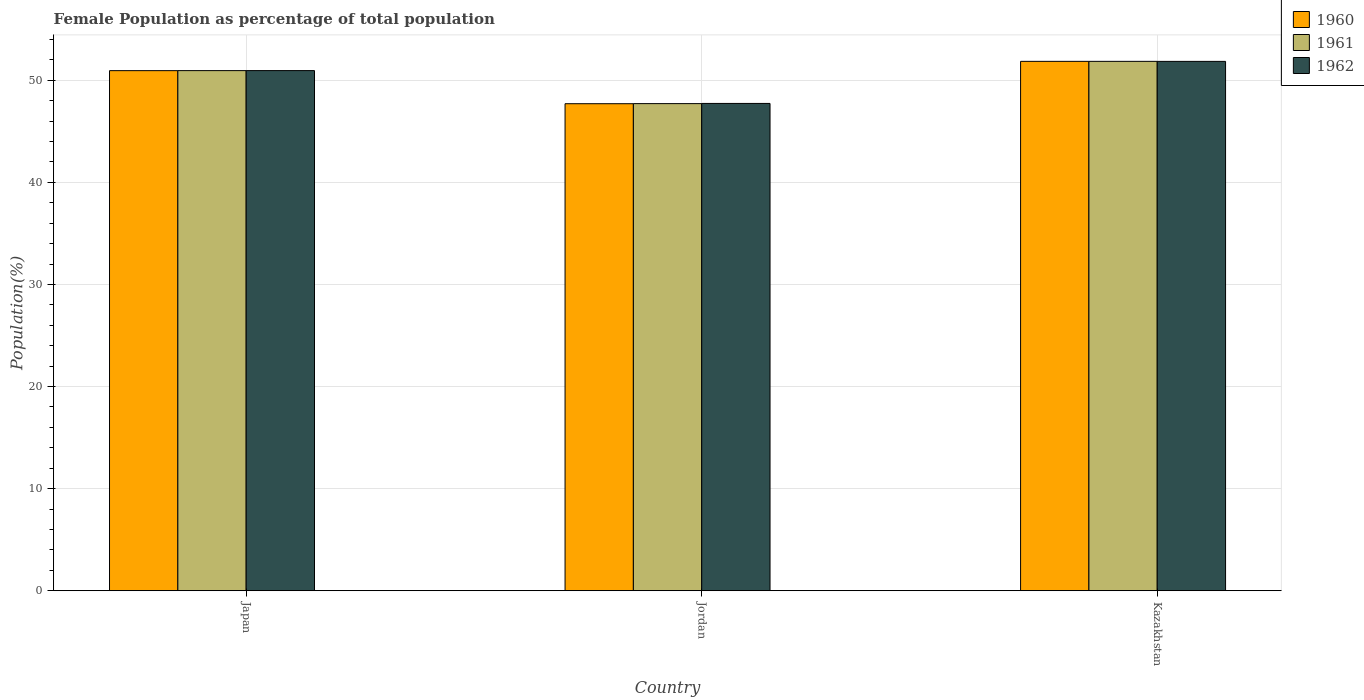How many bars are there on the 2nd tick from the left?
Your response must be concise. 3. How many bars are there on the 3rd tick from the right?
Your answer should be compact. 3. What is the label of the 3rd group of bars from the left?
Offer a very short reply. Kazakhstan. What is the female population in in 1960 in Kazakhstan?
Give a very brief answer. 51.85. Across all countries, what is the maximum female population in in 1962?
Offer a terse response. 51.85. Across all countries, what is the minimum female population in in 1961?
Give a very brief answer. 47.71. In which country was the female population in in 1961 maximum?
Ensure brevity in your answer.  Kazakhstan. In which country was the female population in in 1960 minimum?
Keep it short and to the point. Jordan. What is the total female population in in 1961 in the graph?
Make the answer very short. 150.51. What is the difference between the female population in in 1960 in Jordan and that in Kazakhstan?
Provide a short and direct response. -4.15. What is the difference between the female population in in 1962 in Kazakhstan and the female population in in 1961 in Japan?
Provide a short and direct response. 0.9. What is the average female population in in 1961 per country?
Your response must be concise. 50.17. What is the difference between the female population in of/in 1962 and female population in of/in 1961 in Kazakhstan?
Provide a short and direct response. -0. In how many countries, is the female population in in 1962 greater than 8 %?
Offer a very short reply. 3. What is the ratio of the female population in in 1962 in Japan to that in Kazakhstan?
Your response must be concise. 0.98. Is the difference between the female population in in 1962 in Japan and Jordan greater than the difference between the female population in in 1961 in Japan and Jordan?
Offer a terse response. No. What is the difference between the highest and the second highest female population in in 1961?
Offer a terse response. -0.91. What is the difference between the highest and the lowest female population in in 1962?
Your answer should be compact. 4.12. Is the sum of the female population in in 1960 in Japan and Jordan greater than the maximum female population in in 1961 across all countries?
Your response must be concise. Yes. What does the 1st bar from the right in Kazakhstan represents?
Keep it short and to the point. 1962. Is it the case that in every country, the sum of the female population in in 1960 and female population in in 1962 is greater than the female population in in 1961?
Offer a very short reply. Yes. How many bars are there?
Give a very brief answer. 9. What is the difference between two consecutive major ticks on the Y-axis?
Provide a short and direct response. 10. How are the legend labels stacked?
Your response must be concise. Vertical. What is the title of the graph?
Your answer should be very brief. Female Population as percentage of total population. What is the label or title of the X-axis?
Ensure brevity in your answer.  Country. What is the label or title of the Y-axis?
Ensure brevity in your answer.  Population(%). What is the Population(%) in 1960 in Japan?
Make the answer very short. 50.94. What is the Population(%) in 1961 in Japan?
Ensure brevity in your answer.  50.94. What is the Population(%) in 1962 in Japan?
Your answer should be compact. 50.95. What is the Population(%) in 1960 in Jordan?
Keep it short and to the point. 47.7. What is the Population(%) in 1961 in Jordan?
Your response must be concise. 47.71. What is the Population(%) of 1962 in Jordan?
Offer a terse response. 47.73. What is the Population(%) of 1960 in Kazakhstan?
Offer a terse response. 51.85. What is the Population(%) in 1961 in Kazakhstan?
Provide a succinct answer. 51.85. What is the Population(%) of 1962 in Kazakhstan?
Make the answer very short. 51.85. Across all countries, what is the maximum Population(%) of 1960?
Provide a short and direct response. 51.85. Across all countries, what is the maximum Population(%) of 1961?
Ensure brevity in your answer.  51.85. Across all countries, what is the maximum Population(%) in 1962?
Your answer should be very brief. 51.85. Across all countries, what is the minimum Population(%) of 1960?
Your answer should be very brief. 47.7. Across all countries, what is the minimum Population(%) of 1961?
Your answer should be compact. 47.71. Across all countries, what is the minimum Population(%) in 1962?
Provide a short and direct response. 47.73. What is the total Population(%) of 1960 in the graph?
Offer a very short reply. 150.5. What is the total Population(%) in 1961 in the graph?
Ensure brevity in your answer.  150.51. What is the total Population(%) of 1962 in the graph?
Keep it short and to the point. 150.52. What is the difference between the Population(%) in 1960 in Japan and that in Jordan?
Offer a very short reply. 3.24. What is the difference between the Population(%) in 1961 in Japan and that in Jordan?
Provide a short and direct response. 3.23. What is the difference between the Population(%) in 1962 in Japan and that in Jordan?
Make the answer very short. 3.21. What is the difference between the Population(%) of 1960 in Japan and that in Kazakhstan?
Give a very brief answer. -0.91. What is the difference between the Population(%) of 1961 in Japan and that in Kazakhstan?
Your answer should be very brief. -0.91. What is the difference between the Population(%) of 1962 in Japan and that in Kazakhstan?
Keep it short and to the point. -0.9. What is the difference between the Population(%) of 1960 in Jordan and that in Kazakhstan?
Your response must be concise. -4.15. What is the difference between the Population(%) of 1961 in Jordan and that in Kazakhstan?
Offer a terse response. -4.14. What is the difference between the Population(%) in 1962 in Jordan and that in Kazakhstan?
Offer a very short reply. -4.12. What is the difference between the Population(%) in 1960 in Japan and the Population(%) in 1961 in Jordan?
Ensure brevity in your answer.  3.23. What is the difference between the Population(%) in 1960 in Japan and the Population(%) in 1962 in Jordan?
Your answer should be compact. 3.21. What is the difference between the Population(%) of 1961 in Japan and the Population(%) of 1962 in Jordan?
Give a very brief answer. 3.21. What is the difference between the Population(%) in 1960 in Japan and the Population(%) in 1961 in Kazakhstan?
Offer a very short reply. -0.91. What is the difference between the Population(%) in 1960 in Japan and the Population(%) in 1962 in Kazakhstan?
Keep it short and to the point. -0.91. What is the difference between the Population(%) of 1961 in Japan and the Population(%) of 1962 in Kazakhstan?
Ensure brevity in your answer.  -0.9. What is the difference between the Population(%) of 1960 in Jordan and the Population(%) of 1961 in Kazakhstan?
Offer a terse response. -4.15. What is the difference between the Population(%) in 1960 in Jordan and the Population(%) in 1962 in Kazakhstan?
Ensure brevity in your answer.  -4.15. What is the difference between the Population(%) in 1961 in Jordan and the Population(%) in 1962 in Kazakhstan?
Your answer should be very brief. -4.14. What is the average Population(%) in 1960 per country?
Provide a short and direct response. 50.17. What is the average Population(%) in 1961 per country?
Provide a short and direct response. 50.17. What is the average Population(%) in 1962 per country?
Make the answer very short. 50.17. What is the difference between the Population(%) in 1960 and Population(%) in 1961 in Japan?
Provide a short and direct response. -0. What is the difference between the Population(%) of 1960 and Population(%) of 1962 in Japan?
Provide a succinct answer. -0. What is the difference between the Population(%) of 1961 and Population(%) of 1962 in Japan?
Your answer should be compact. -0. What is the difference between the Population(%) in 1960 and Population(%) in 1961 in Jordan?
Ensure brevity in your answer.  -0.01. What is the difference between the Population(%) in 1960 and Population(%) in 1962 in Jordan?
Give a very brief answer. -0.03. What is the difference between the Population(%) of 1961 and Population(%) of 1962 in Jordan?
Ensure brevity in your answer.  -0.02. What is the difference between the Population(%) in 1960 and Population(%) in 1962 in Kazakhstan?
Offer a very short reply. 0. What is the difference between the Population(%) in 1961 and Population(%) in 1962 in Kazakhstan?
Provide a succinct answer. 0. What is the ratio of the Population(%) in 1960 in Japan to that in Jordan?
Ensure brevity in your answer.  1.07. What is the ratio of the Population(%) of 1961 in Japan to that in Jordan?
Make the answer very short. 1.07. What is the ratio of the Population(%) of 1962 in Japan to that in Jordan?
Make the answer very short. 1.07. What is the ratio of the Population(%) in 1960 in Japan to that in Kazakhstan?
Keep it short and to the point. 0.98. What is the ratio of the Population(%) of 1961 in Japan to that in Kazakhstan?
Ensure brevity in your answer.  0.98. What is the ratio of the Population(%) of 1962 in Japan to that in Kazakhstan?
Offer a terse response. 0.98. What is the ratio of the Population(%) of 1961 in Jordan to that in Kazakhstan?
Provide a short and direct response. 0.92. What is the ratio of the Population(%) of 1962 in Jordan to that in Kazakhstan?
Give a very brief answer. 0.92. What is the difference between the highest and the second highest Population(%) in 1960?
Keep it short and to the point. 0.91. What is the difference between the highest and the second highest Population(%) in 1961?
Your answer should be very brief. 0.91. What is the difference between the highest and the second highest Population(%) in 1962?
Your answer should be very brief. 0.9. What is the difference between the highest and the lowest Population(%) in 1960?
Keep it short and to the point. 4.15. What is the difference between the highest and the lowest Population(%) of 1961?
Your answer should be very brief. 4.14. What is the difference between the highest and the lowest Population(%) in 1962?
Provide a succinct answer. 4.12. 